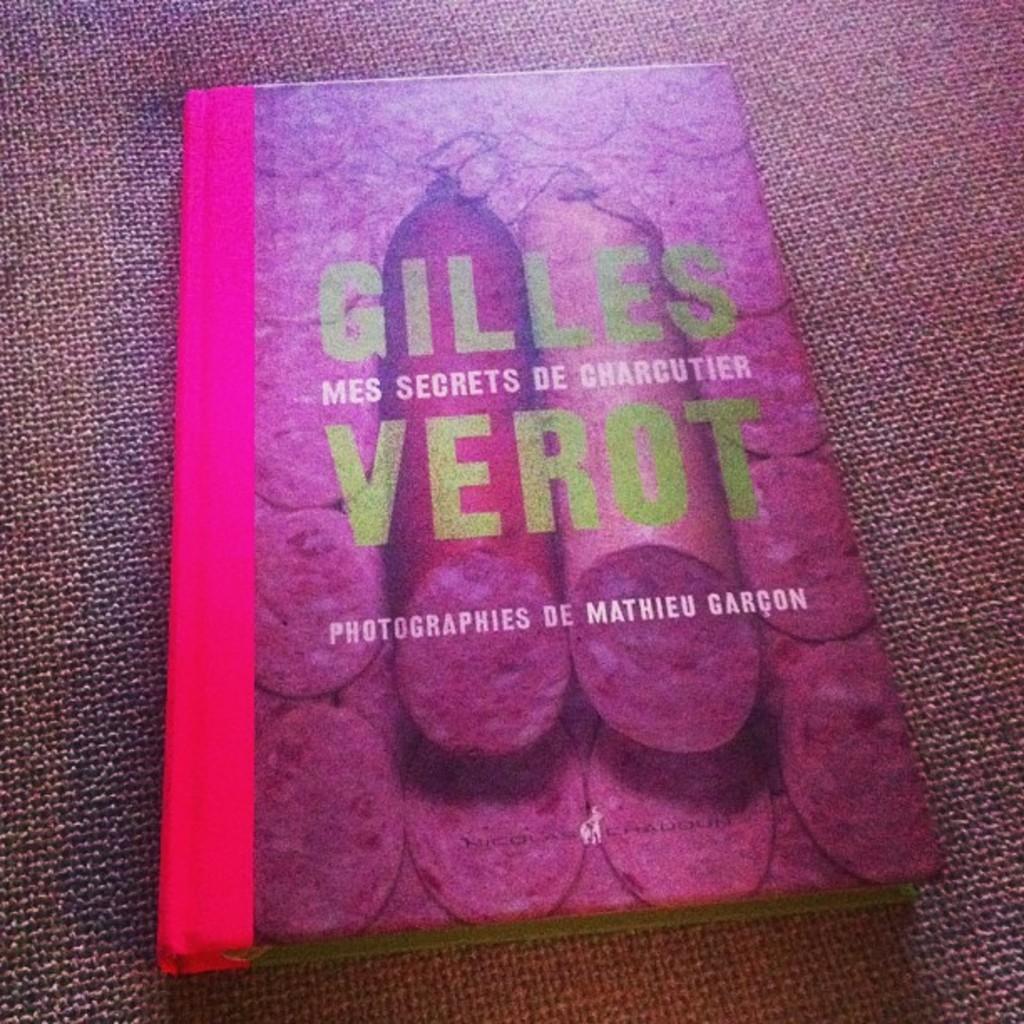What is this book about?
Provide a succinct answer. Mes secrets de charcutier. Who's the author?
Offer a terse response. Gilles verot. 